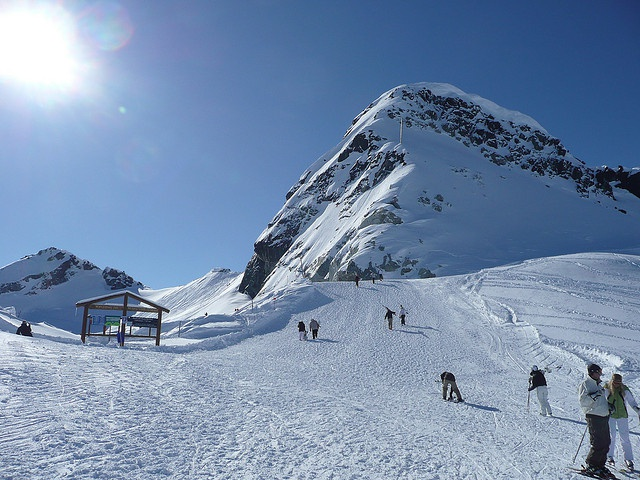Describe the objects in this image and their specific colors. I can see people in lavender, black, gray, and darkgray tones, people in lavender, gray, black, and darkgreen tones, people in lavender, black, and gray tones, people in lavender, black, gray, and darkgray tones, and skis in lavender, black, gray, and darkgray tones in this image. 